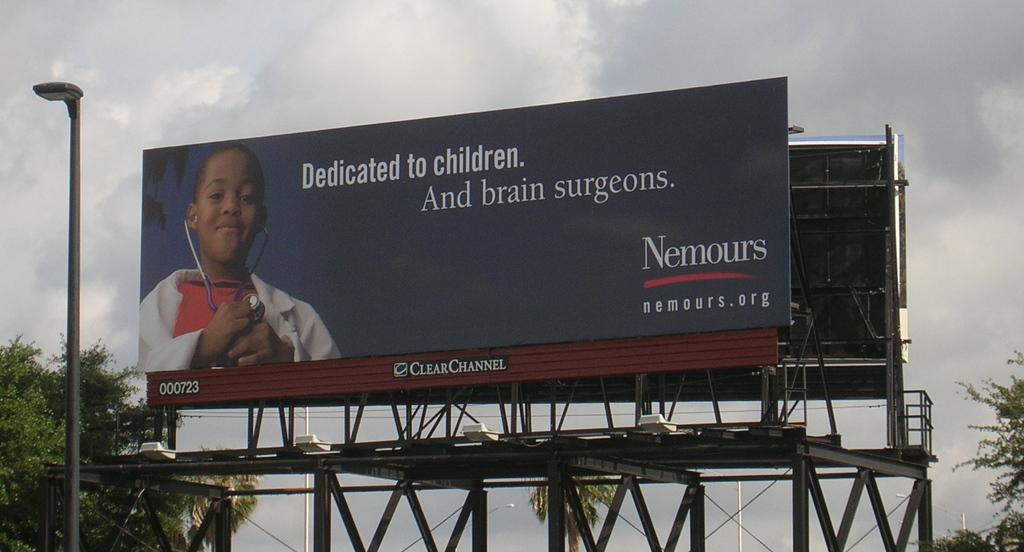<image>
Describe the image concisely. A billboard by Nemours shows a child dressed as a doctor. 